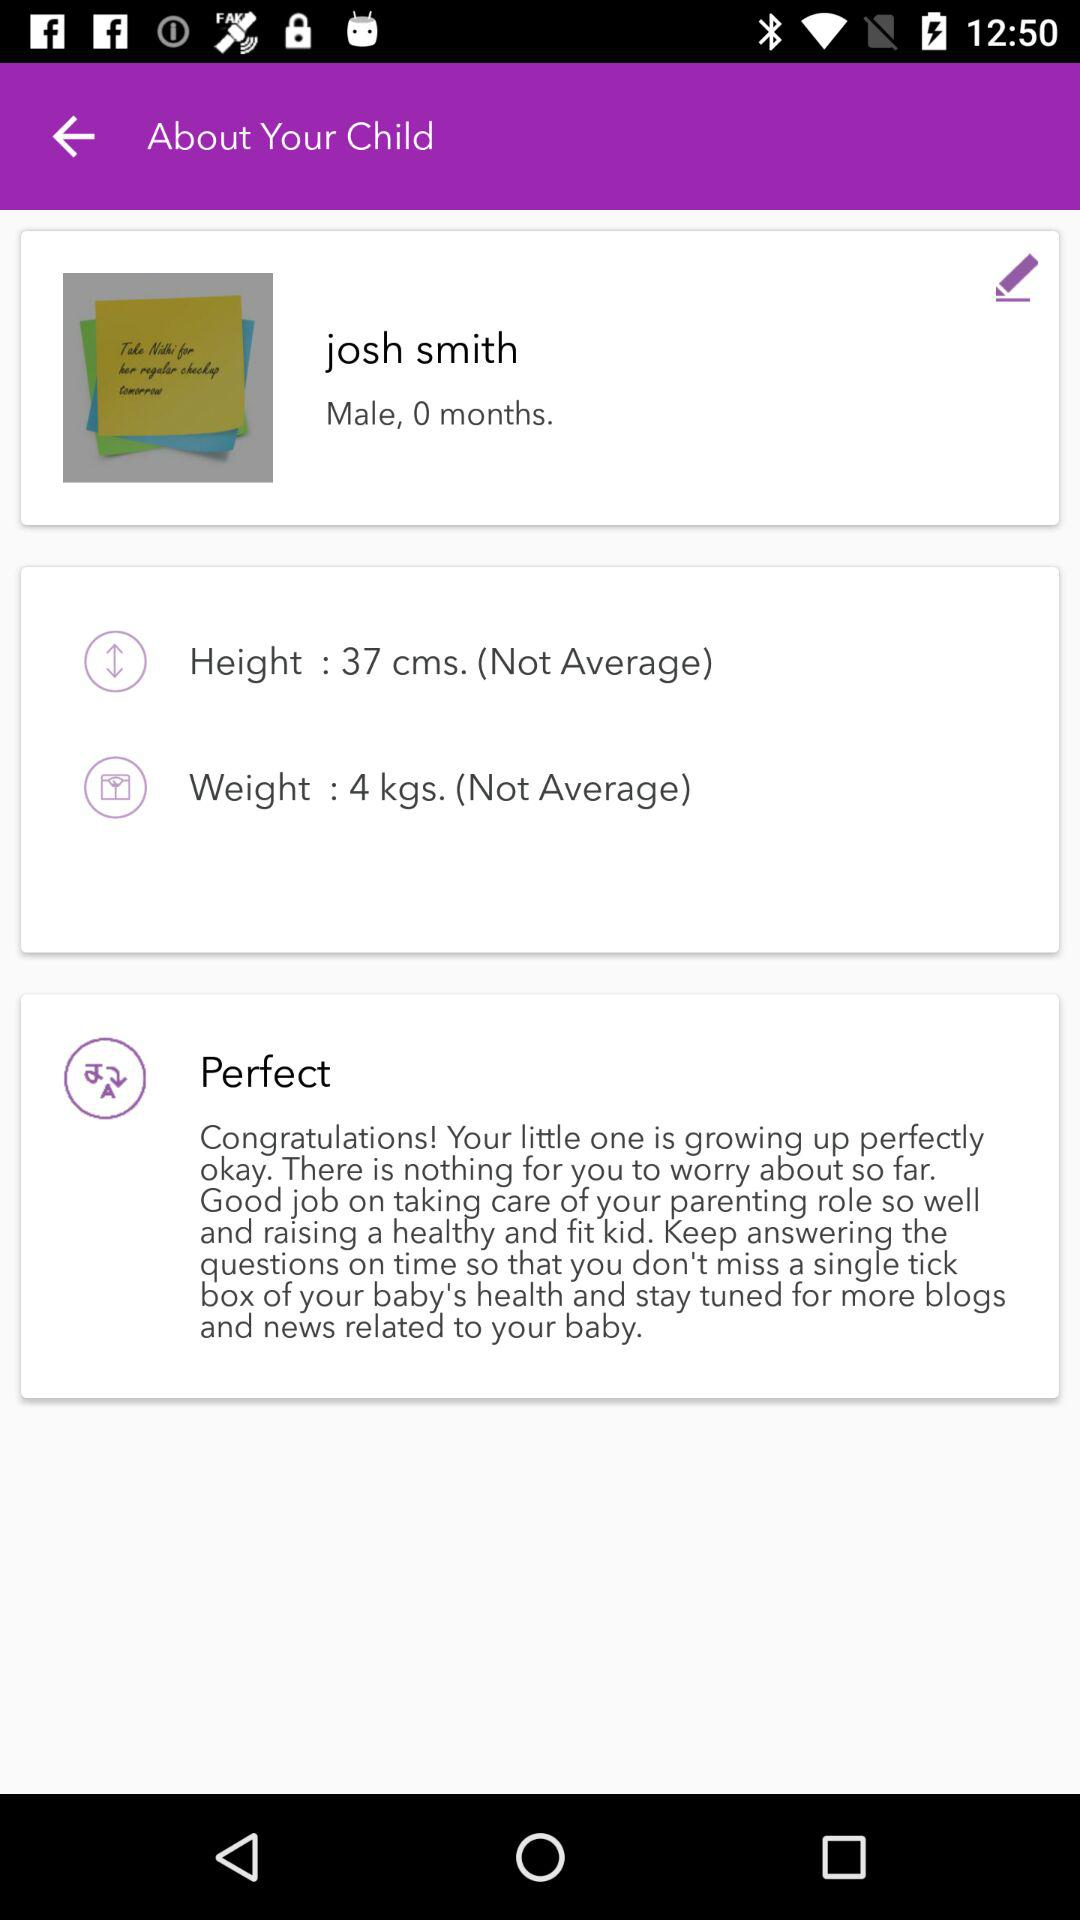How old is the child? The child is 0 months old. 